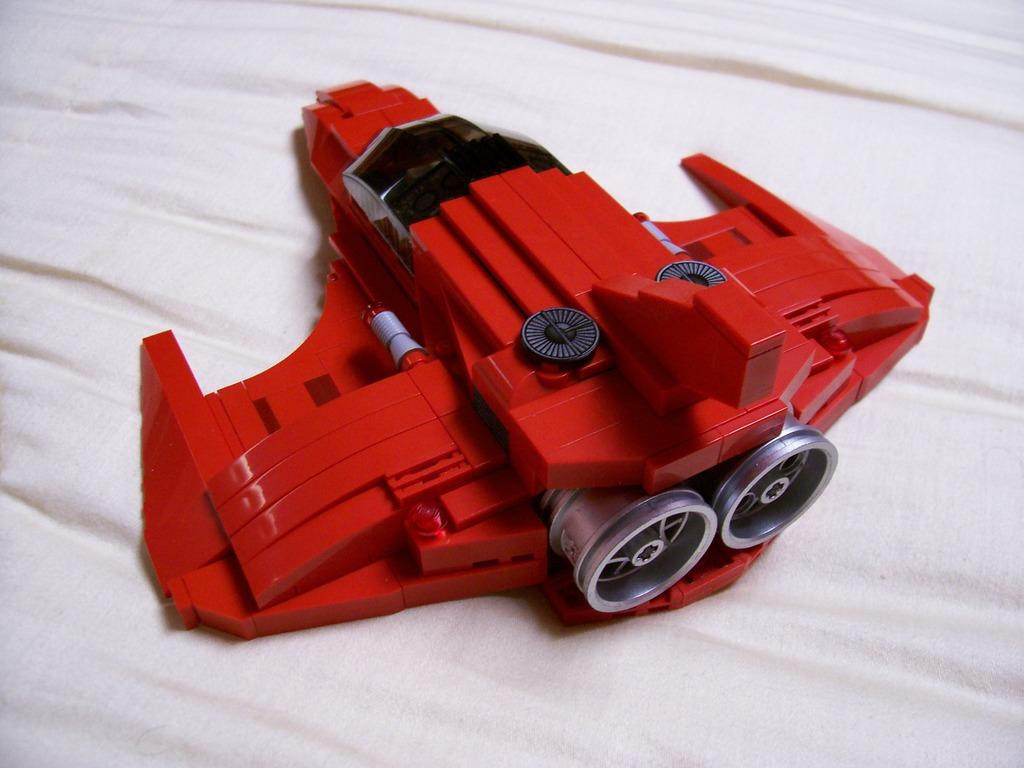What object is present in the image that resembles a toy? There is a toy in the image. What is the toy placed on in the image? The toy is placed on a cloth. Where is the toy and cloth located in the image? The toy and cloth are in the center of the image. How many legs can be seen supporting the toy in the image? There are no legs visible supporting the toy in the image, as it is a toy placed on a cloth. What type of servant is present in the image? There is no servant present in the image; it features a toy placed on a cloth. 